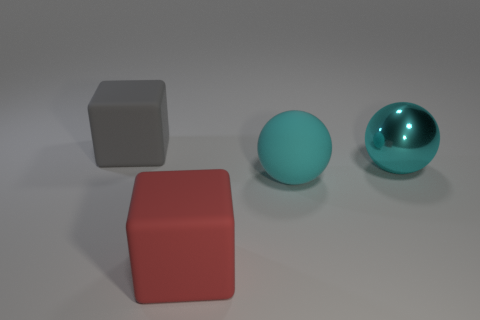What size is the shiny object that is the same color as the rubber ball?
Offer a very short reply. Large. What is the material of the other sphere that is the same color as the big matte sphere?
Your answer should be very brief. Metal. What is the size of the gray object that is behind the shiny ball?
Ensure brevity in your answer.  Large. Is there a cube of the same color as the big rubber ball?
Offer a terse response. No. Do the rubber cube in front of the gray matte block and the large gray thing have the same size?
Provide a short and direct response. Yes. What is the color of the metallic object?
Make the answer very short. Cyan. There is a big rubber thing in front of the ball in front of the big metal thing; what color is it?
Your answer should be compact. Red. Is there a yellow object made of the same material as the red object?
Ensure brevity in your answer.  No. What material is the large cube right of the gray thing that is to the left of the metallic sphere?
Your response must be concise. Rubber. What number of gray matte things are the same shape as the cyan rubber object?
Your response must be concise. 0. 